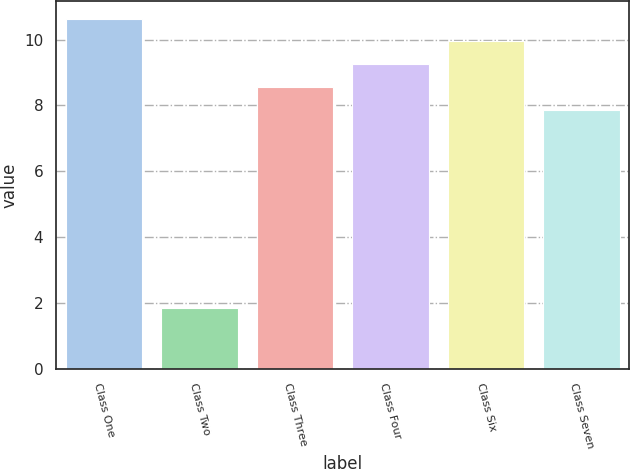<chart> <loc_0><loc_0><loc_500><loc_500><bar_chart><fcel>Class One<fcel>Class Two<fcel>Class Three<fcel>Class Four<fcel>Class Six<fcel>Class Seven<nl><fcel>10.63<fcel>1.84<fcel>8.56<fcel>9.25<fcel>9.94<fcel>7.87<nl></chart> 